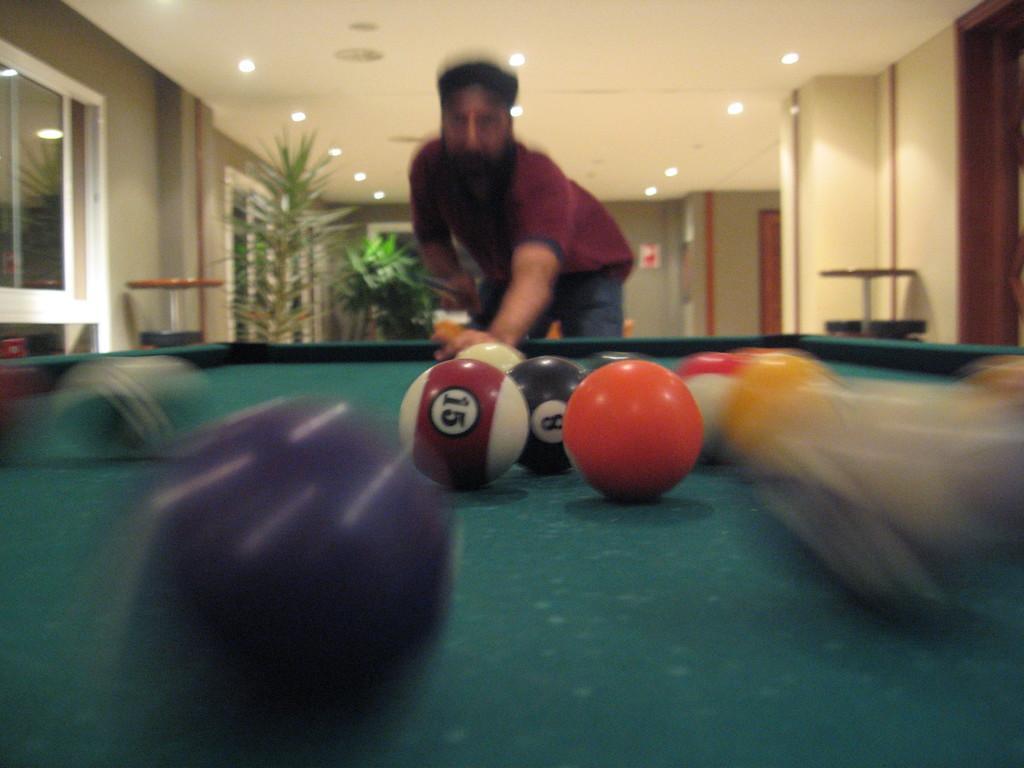Can you describe this image briefly? In the image we can see a man standing and wearing clothes. There are snooker balls and a snooker table. We can even see there is a plant, lights and windows. 